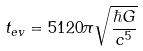Convert formula to latex. <formula><loc_0><loc_0><loc_500><loc_500>t _ { e v } = 5 1 2 0 \pi \sqrt { \frac { \hbar { G } } { c ^ { 5 } } }</formula> 